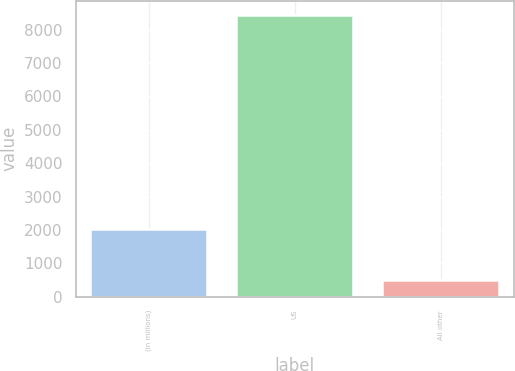<chart> <loc_0><loc_0><loc_500><loc_500><bar_chart><fcel>(in millions)<fcel>US<fcel>All other<nl><fcel>2016<fcel>8438<fcel>492<nl></chart> 